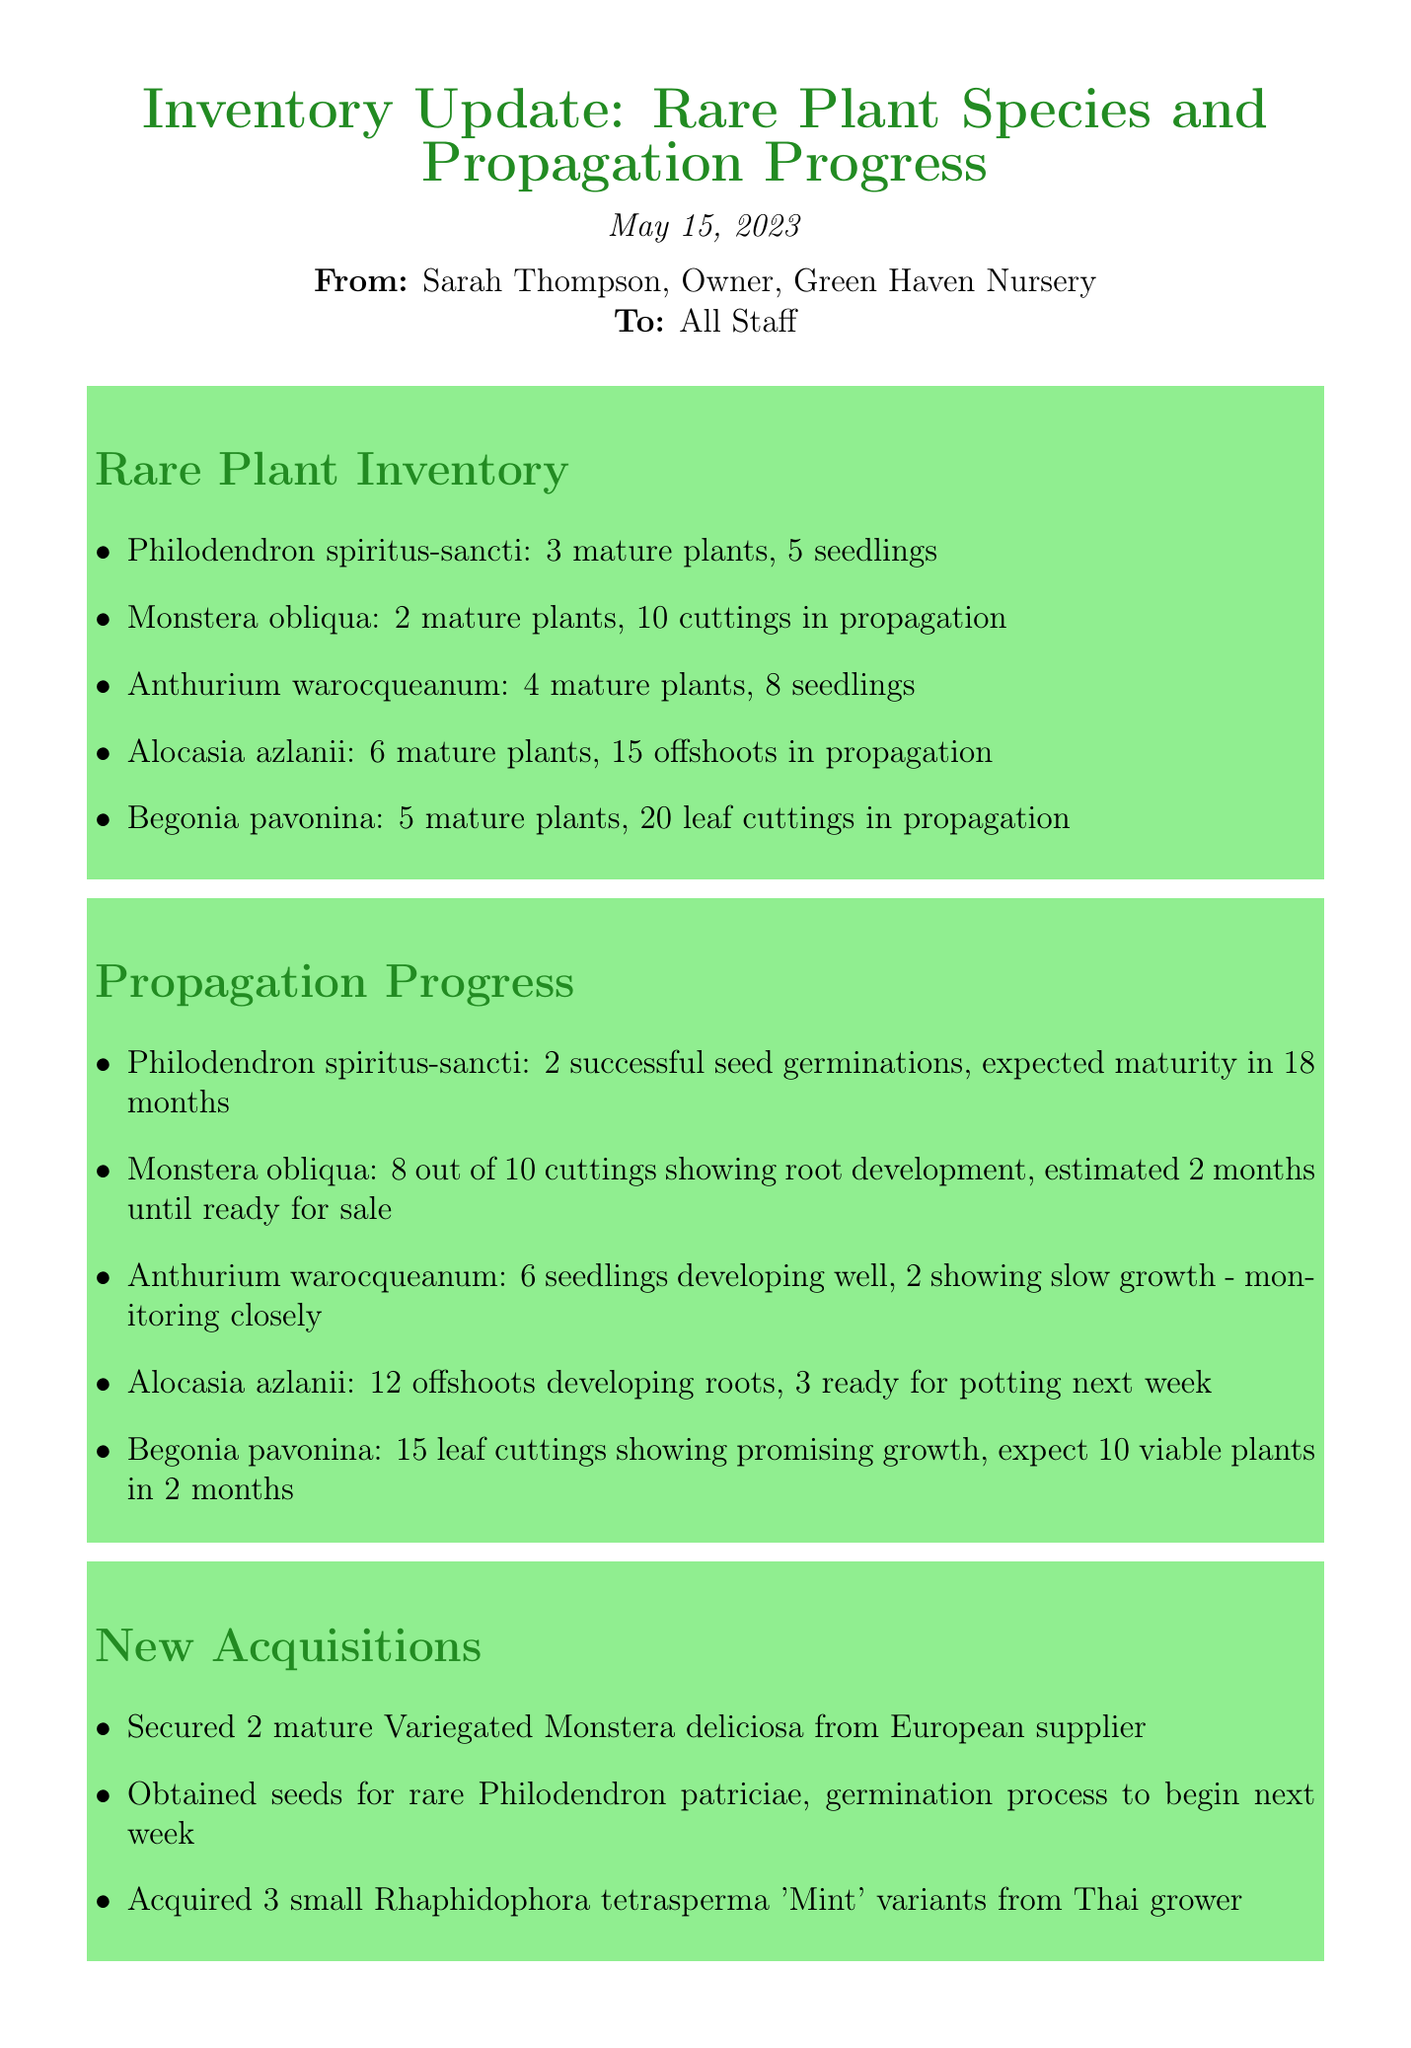What is the date of the memo? The date of the memo is explicitly stated at the beginning of the document.
Answer: May 15, 2023 Who is the sender of the memo? The sender of the memo is mentioned right below the date.
Answer: Sarah Thompson How many mature plants of Philodendron spiritus-sancti are there? The number of mature plants is listed in the Rare Plant Inventory section.
Answer: 3 mature plants What issue is affecting the Begonia pavonina seedlings? The specific challenge affecting the seedlings is outlined in the Challenges and Action Items section.
Answer: Powdery mildew How many seedlings of Anthurium warocqueanum are developing well? The details about the seedlings are provided in the Propagation Progress section.
Answer: 6 seedlings What new acquisitions were made for the plant nursery? The new acquisitions are listed in a specific section of the memo.
Answer: 2 mature Variegated Monstera deliciosa, seeds for rare Philodendron patriciae, 3 small Rhaphidophora tetrasperma 'Mint' variants What is the growth expectation for Begonia pavonina leaf cuttings? The expected outcome for the leaf cuttings is described in the Propagation Progress section.
Answer: Expect 10 viable plants in 2 months By how much should the propagation efforts for Monstera obliqua be increased? The document specifies the increase required in the Challenges and Action Items section.
Answer: 50% 